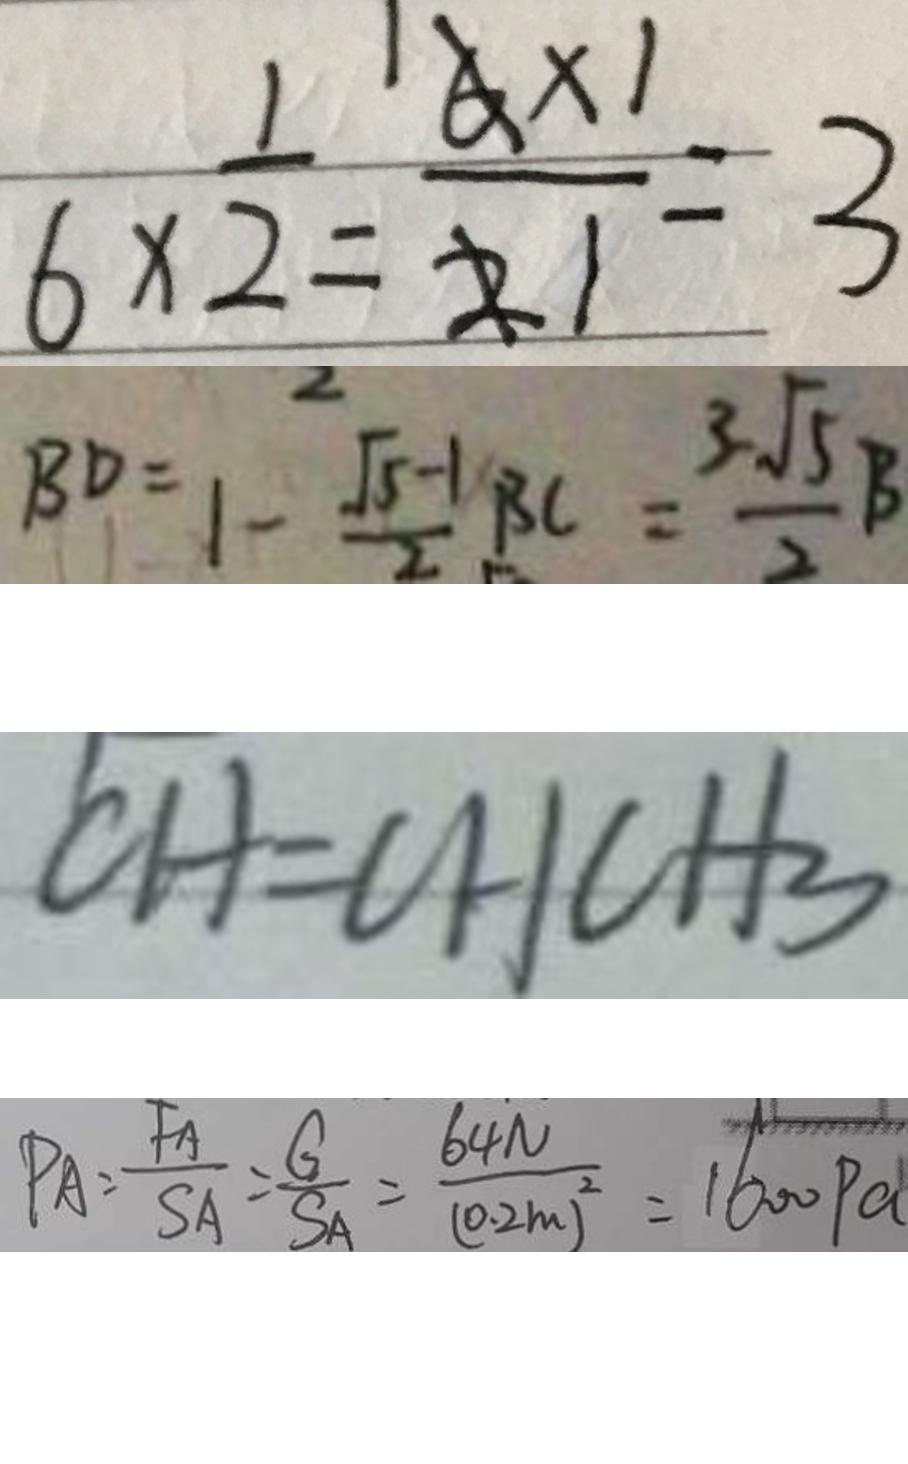Convert formula to latex. <formula><loc_0><loc_0><loc_500><loc_500>6 \times \frac { 1 } { 2 } = \frac { 6 \times 1 } { 2 } = 3 
 B D = 1 - \frac { \sqrt { 5 } - 1 } { 2 } B C = \frac { 3 \sqrt { 5 } } { 2 } B 
 C H = C H C H _ { 3 } 
 P A = \frac { F _ { A } } { S A } = \frac { G } { S A } = \frac { 6 4 N } { ( 0 . 2 m ) ^ { 2 } } = 1 6 0 0 P a</formula> 